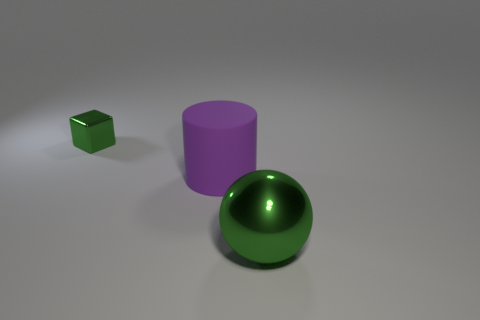The object that is both on the left side of the sphere and in front of the tiny green cube is what color?
Make the answer very short. Purple. How many large cylinders are in front of the metal thing that is to the right of the small shiny block?
Make the answer very short. 0. What color is the cylinder?
Ensure brevity in your answer.  Purple. What number of things are large purple cylinders or small green metal cubes?
Ensure brevity in your answer.  2. There is a large thing that is behind the metal object that is on the right side of the green block; what is its shape?
Your answer should be compact. Cylinder. How many other objects are there of the same material as the cube?
Your response must be concise. 1. Are the large green thing and the green thing to the left of the green sphere made of the same material?
Offer a very short reply. Yes. How many things are tiny blocks on the left side of the large matte object or metal things to the right of the small green metal thing?
Give a very brief answer. 2. What number of other objects are there of the same color as the large cylinder?
Ensure brevity in your answer.  0. Are there more large things that are on the left side of the big green metallic thing than tiny shiny objects behind the small metallic thing?
Your answer should be very brief. Yes. 